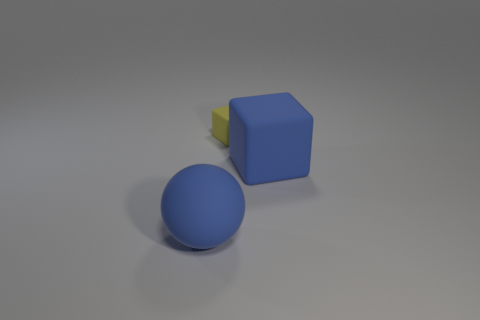What number of things are both in front of the tiny yellow object and behind the blue rubber sphere?
Make the answer very short. 1. Is the number of cubes behind the big rubber block the same as the number of yellow things that are to the right of the small yellow thing?
Ensure brevity in your answer.  No. There is a thing that is on the left side of the yellow rubber object; does it have the same size as the matte block that is in front of the small object?
Provide a short and direct response. Yes. What material is the object that is both to the left of the large blue block and in front of the small yellow cube?
Ensure brevity in your answer.  Rubber. Is the number of large yellow metallic balls less than the number of big things?
Offer a very short reply. Yes. There is a yellow object to the right of the object to the left of the small yellow thing; what size is it?
Provide a short and direct response. Small. What is the shape of the blue object that is to the left of the matte block that is behind the blue matte thing on the right side of the large matte ball?
Give a very brief answer. Sphere. The large object that is the same material as the large block is what color?
Offer a terse response. Blue. The tiny block that is to the left of the rubber object that is to the right of the rubber block that is to the left of the blue cube is what color?
Keep it short and to the point. Yellow. What number of cylinders are large cyan rubber objects or blue rubber objects?
Your response must be concise. 0. 